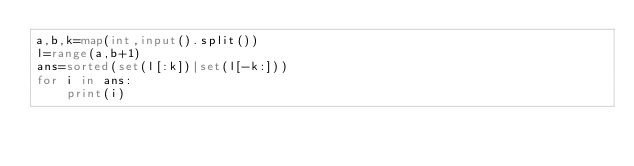<code> <loc_0><loc_0><loc_500><loc_500><_Python_>a,b,k=map(int,input().split())
l=range(a,b+1)
ans=sorted(set(l[:k])|set(l[-k:]))
for i in ans:
    print(i)</code> 